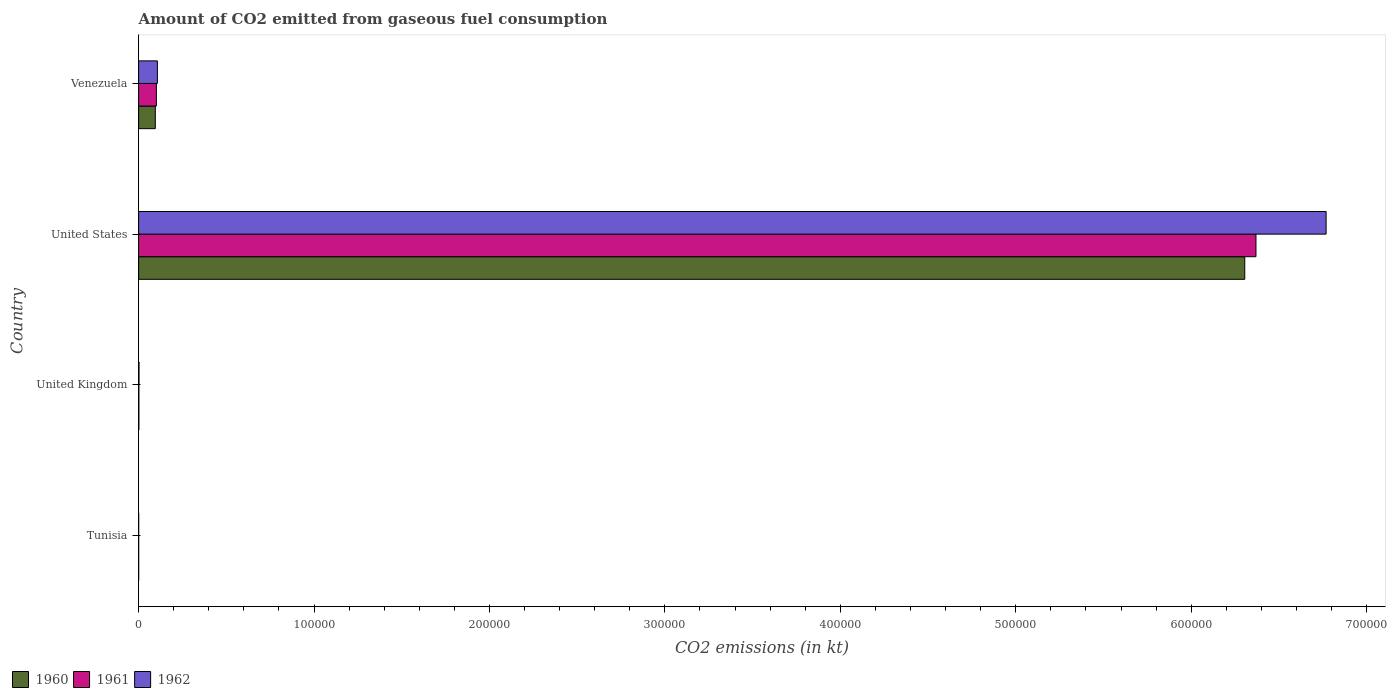How many different coloured bars are there?
Ensure brevity in your answer.  3. Are the number of bars on each tick of the Y-axis equal?
Offer a terse response. Yes. How many bars are there on the 1st tick from the top?
Keep it short and to the point. 3. How many bars are there on the 2nd tick from the bottom?
Give a very brief answer. 3. What is the label of the 3rd group of bars from the top?
Provide a short and direct response. United Kingdom. In how many cases, is the number of bars for a given country not equal to the number of legend labels?
Offer a very short reply. 0. What is the amount of CO2 emitted in 1962 in United Kingdom?
Keep it short and to the point. 216.35. Across all countries, what is the maximum amount of CO2 emitted in 1962?
Provide a short and direct response. 6.77e+05. Across all countries, what is the minimum amount of CO2 emitted in 1961?
Ensure brevity in your answer.  14.67. In which country was the amount of CO2 emitted in 1962 minimum?
Ensure brevity in your answer.  Tunisia. What is the total amount of CO2 emitted in 1960 in the graph?
Your answer should be very brief. 6.40e+05. What is the difference between the amount of CO2 emitted in 1961 in Tunisia and that in United Kingdom?
Provide a succinct answer. -135.68. What is the difference between the amount of CO2 emitted in 1960 in United States and the amount of CO2 emitted in 1961 in Venezuela?
Offer a terse response. 6.20e+05. What is the average amount of CO2 emitted in 1961 per country?
Keep it short and to the point. 1.62e+05. What is the difference between the amount of CO2 emitted in 1961 and amount of CO2 emitted in 1962 in Tunisia?
Offer a very short reply. 0. In how many countries, is the amount of CO2 emitted in 1961 greater than 660000 kt?
Keep it short and to the point. 0. What is the ratio of the amount of CO2 emitted in 1962 in United Kingdom to that in United States?
Provide a short and direct response. 0. Is the amount of CO2 emitted in 1960 in United Kingdom less than that in United States?
Offer a very short reply. Yes. What is the difference between the highest and the second highest amount of CO2 emitted in 1961?
Ensure brevity in your answer.  6.27e+05. What is the difference between the highest and the lowest amount of CO2 emitted in 1961?
Your response must be concise. 6.37e+05. In how many countries, is the amount of CO2 emitted in 1962 greater than the average amount of CO2 emitted in 1962 taken over all countries?
Provide a succinct answer. 1. What does the 2nd bar from the top in Venezuela represents?
Provide a succinct answer. 1961. Is it the case that in every country, the sum of the amount of CO2 emitted in 1962 and amount of CO2 emitted in 1960 is greater than the amount of CO2 emitted in 1961?
Your response must be concise. Yes. How many bars are there?
Provide a succinct answer. 12. Are all the bars in the graph horizontal?
Offer a very short reply. Yes. How many countries are there in the graph?
Keep it short and to the point. 4. What is the difference between two consecutive major ticks on the X-axis?
Provide a succinct answer. 1.00e+05. Does the graph contain grids?
Your response must be concise. No. How many legend labels are there?
Provide a short and direct response. 3. How are the legend labels stacked?
Your answer should be very brief. Horizontal. What is the title of the graph?
Offer a terse response. Amount of CO2 emitted from gaseous fuel consumption. Does "1965" appear as one of the legend labels in the graph?
Your answer should be compact. No. What is the label or title of the X-axis?
Make the answer very short. CO2 emissions (in kt). What is the CO2 emissions (in kt) of 1960 in Tunisia?
Ensure brevity in your answer.  14.67. What is the CO2 emissions (in kt) of 1961 in Tunisia?
Keep it short and to the point. 14.67. What is the CO2 emissions (in kt) in 1962 in Tunisia?
Ensure brevity in your answer.  14.67. What is the CO2 emissions (in kt) of 1960 in United Kingdom?
Offer a very short reply. 150.35. What is the CO2 emissions (in kt) of 1961 in United Kingdom?
Make the answer very short. 150.35. What is the CO2 emissions (in kt) in 1962 in United Kingdom?
Keep it short and to the point. 216.35. What is the CO2 emissions (in kt) in 1960 in United States?
Offer a very short reply. 6.31e+05. What is the CO2 emissions (in kt) in 1961 in United States?
Make the answer very short. 6.37e+05. What is the CO2 emissions (in kt) in 1962 in United States?
Offer a very short reply. 6.77e+05. What is the CO2 emissions (in kt) in 1960 in Venezuela?
Give a very brief answer. 9508.53. What is the CO2 emissions (in kt) in 1961 in Venezuela?
Provide a succinct answer. 1.01e+04. What is the CO2 emissions (in kt) in 1962 in Venezuela?
Offer a very short reply. 1.07e+04. Across all countries, what is the maximum CO2 emissions (in kt) in 1960?
Your answer should be compact. 6.31e+05. Across all countries, what is the maximum CO2 emissions (in kt) in 1961?
Ensure brevity in your answer.  6.37e+05. Across all countries, what is the maximum CO2 emissions (in kt) in 1962?
Provide a short and direct response. 6.77e+05. Across all countries, what is the minimum CO2 emissions (in kt) in 1960?
Make the answer very short. 14.67. Across all countries, what is the minimum CO2 emissions (in kt) of 1961?
Your answer should be very brief. 14.67. Across all countries, what is the minimum CO2 emissions (in kt) in 1962?
Provide a short and direct response. 14.67. What is the total CO2 emissions (in kt) in 1960 in the graph?
Offer a terse response. 6.40e+05. What is the total CO2 emissions (in kt) of 1961 in the graph?
Ensure brevity in your answer.  6.47e+05. What is the total CO2 emissions (in kt) in 1962 in the graph?
Provide a short and direct response. 6.88e+05. What is the difference between the CO2 emissions (in kt) of 1960 in Tunisia and that in United Kingdom?
Keep it short and to the point. -135.68. What is the difference between the CO2 emissions (in kt) in 1961 in Tunisia and that in United Kingdom?
Offer a very short reply. -135.68. What is the difference between the CO2 emissions (in kt) of 1962 in Tunisia and that in United Kingdom?
Offer a very short reply. -201.69. What is the difference between the CO2 emissions (in kt) of 1960 in Tunisia and that in United States?
Give a very brief answer. -6.31e+05. What is the difference between the CO2 emissions (in kt) of 1961 in Tunisia and that in United States?
Make the answer very short. -6.37e+05. What is the difference between the CO2 emissions (in kt) of 1962 in Tunisia and that in United States?
Offer a terse response. -6.77e+05. What is the difference between the CO2 emissions (in kt) in 1960 in Tunisia and that in Venezuela?
Keep it short and to the point. -9493.86. What is the difference between the CO2 emissions (in kt) in 1961 in Tunisia and that in Venezuela?
Keep it short and to the point. -1.01e+04. What is the difference between the CO2 emissions (in kt) in 1962 in Tunisia and that in Venezuela?
Your answer should be very brief. -1.07e+04. What is the difference between the CO2 emissions (in kt) of 1960 in United Kingdom and that in United States?
Give a very brief answer. -6.30e+05. What is the difference between the CO2 emissions (in kt) of 1961 in United Kingdom and that in United States?
Offer a terse response. -6.37e+05. What is the difference between the CO2 emissions (in kt) of 1962 in United Kingdom and that in United States?
Your answer should be compact. -6.77e+05. What is the difference between the CO2 emissions (in kt) in 1960 in United Kingdom and that in Venezuela?
Ensure brevity in your answer.  -9358.18. What is the difference between the CO2 emissions (in kt) of 1961 in United Kingdom and that in Venezuela?
Your answer should be very brief. -9970.57. What is the difference between the CO2 emissions (in kt) in 1962 in United Kingdom and that in Venezuela?
Offer a terse response. -1.05e+04. What is the difference between the CO2 emissions (in kt) in 1960 in United States and that in Venezuela?
Make the answer very short. 6.21e+05. What is the difference between the CO2 emissions (in kt) in 1961 in United States and that in Venezuela?
Make the answer very short. 6.27e+05. What is the difference between the CO2 emissions (in kt) of 1962 in United States and that in Venezuela?
Your answer should be compact. 6.66e+05. What is the difference between the CO2 emissions (in kt) in 1960 in Tunisia and the CO2 emissions (in kt) in 1961 in United Kingdom?
Offer a terse response. -135.68. What is the difference between the CO2 emissions (in kt) of 1960 in Tunisia and the CO2 emissions (in kt) of 1962 in United Kingdom?
Offer a terse response. -201.69. What is the difference between the CO2 emissions (in kt) of 1961 in Tunisia and the CO2 emissions (in kt) of 1962 in United Kingdom?
Your answer should be very brief. -201.69. What is the difference between the CO2 emissions (in kt) of 1960 in Tunisia and the CO2 emissions (in kt) of 1961 in United States?
Give a very brief answer. -6.37e+05. What is the difference between the CO2 emissions (in kt) in 1960 in Tunisia and the CO2 emissions (in kt) in 1962 in United States?
Ensure brevity in your answer.  -6.77e+05. What is the difference between the CO2 emissions (in kt) of 1961 in Tunisia and the CO2 emissions (in kt) of 1962 in United States?
Offer a terse response. -6.77e+05. What is the difference between the CO2 emissions (in kt) of 1960 in Tunisia and the CO2 emissions (in kt) of 1961 in Venezuela?
Your answer should be very brief. -1.01e+04. What is the difference between the CO2 emissions (in kt) of 1960 in Tunisia and the CO2 emissions (in kt) of 1962 in Venezuela?
Ensure brevity in your answer.  -1.07e+04. What is the difference between the CO2 emissions (in kt) of 1961 in Tunisia and the CO2 emissions (in kt) of 1962 in Venezuela?
Provide a short and direct response. -1.07e+04. What is the difference between the CO2 emissions (in kt) of 1960 in United Kingdom and the CO2 emissions (in kt) of 1961 in United States?
Give a very brief answer. -6.37e+05. What is the difference between the CO2 emissions (in kt) of 1960 in United Kingdom and the CO2 emissions (in kt) of 1962 in United States?
Your response must be concise. -6.77e+05. What is the difference between the CO2 emissions (in kt) in 1961 in United Kingdom and the CO2 emissions (in kt) in 1962 in United States?
Your answer should be compact. -6.77e+05. What is the difference between the CO2 emissions (in kt) of 1960 in United Kingdom and the CO2 emissions (in kt) of 1961 in Venezuela?
Keep it short and to the point. -9970.57. What is the difference between the CO2 emissions (in kt) in 1960 in United Kingdom and the CO2 emissions (in kt) in 1962 in Venezuela?
Your answer should be very brief. -1.05e+04. What is the difference between the CO2 emissions (in kt) in 1961 in United Kingdom and the CO2 emissions (in kt) in 1962 in Venezuela?
Offer a terse response. -1.05e+04. What is the difference between the CO2 emissions (in kt) of 1960 in United States and the CO2 emissions (in kt) of 1961 in Venezuela?
Provide a succinct answer. 6.20e+05. What is the difference between the CO2 emissions (in kt) of 1960 in United States and the CO2 emissions (in kt) of 1962 in Venezuela?
Give a very brief answer. 6.20e+05. What is the difference between the CO2 emissions (in kt) of 1961 in United States and the CO2 emissions (in kt) of 1962 in Venezuela?
Ensure brevity in your answer.  6.26e+05. What is the average CO2 emissions (in kt) of 1960 per country?
Make the answer very short. 1.60e+05. What is the average CO2 emissions (in kt) in 1961 per country?
Provide a short and direct response. 1.62e+05. What is the average CO2 emissions (in kt) of 1962 per country?
Your response must be concise. 1.72e+05. What is the difference between the CO2 emissions (in kt) of 1960 and CO2 emissions (in kt) of 1961 in Tunisia?
Give a very brief answer. 0. What is the difference between the CO2 emissions (in kt) of 1960 and CO2 emissions (in kt) of 1962 in Tunisia?
Give a very brief answer. 0. What is the difference between the CO2 emissions (in kt) of 1961 and CO2 emissions (in kt) of 1962 in Tunisia?
Keep it short and to the point. 0. What is the difference between the CO2 emissions (in kt) of 1960 and CO2 emissions (in kt) of 1962 in United Kingdom?
Give a very brief answer. -66.01. What is the difference between the CO2 emissions (in kt) of 1961 and CO2 emissions (in kt) of 1962 in United Kingdom?
Your response must be concise. -66.01. What is the difference between the CO2 emissions (in kt) of 1960 and CO2 emissions (in kt) of 1961 in United States?
Provide a short and direct response. -6395.25. What is the difference between the CO2 emissions (in kt) of 1960 and CO2 emissions (in kt) of 1962 in United States?
Offer a terse response. -4.64e+04. What is the difference between the CO2 emissions (in kt) of 1961 and CO2 emissions (in kt) of 1962 in United States?
Your answer should be compact. -4.00e+04. What is the difference between the CO2 emissions (in kt) of 1960 and CO2 emissions (in kt) of 1961 in Venezuela?
Offer a very short reply. -612.39. What is the difference between the CO2 emissions (in kt) of 1960 and CO2 emissions (in kt) of 1962 in Venezuela?
Provide a succinct answer. -1191.78. What is the difference between the CO2 emissions (in kt) of 1961 and CO2 emissions (in kt) of 1962 in Venezuela?
Ensure brevity in your answer.  -579.39. What is the ratio of the CO2 emissions (in kt) in 1960 in Tunisia to that in United Kingdom?
Make the answer very short. 0.1. What is the ratio of the CO2 emissions (in kt) in 1961 in Tunisia to that in United Kingdom?
Your response must be concise. 0.1. What is the ratio of the CO2 emissions (in kt) in 1962 in Tunisia to that in United Kingdom?
Keep it short and to the point. 0.07. What is the ratio of the CO2 emissions (in kt) in 1960 in Tunisia to that in United States?
Provide a short and direct response. 0. What is the ratio of the CO2 emissions (in kt) in 1961 in Tunisia to that in United States?
Make the answer very short. 0. What is the ratio of the CO2 emissions (in kt) of 1960 in Tunisia to that in Venezuela?
Make the answer very short. 0. What is the ratio of the CO2 emissions (in kt) in 1961 in Tunisia to that in Venezuela?
Keep it short and to the point. 0. What is the ratio of the CO2 emissions (in kt) in 1962 in Tunisia to that in Venezuela?
Keep it short and to the point. 0. What is the ratio of the CO2 emissions (in kt) of 1960 in United Kingdom to that in Venezuela?
Ensure brevity in your answer.  0.02. What is the ratio of the CO2 emissions (in kt) of 1961 in United Kingdom to that in Venezuela?
Make the answer very short. 0.01. What is the ratio of the CO2 emissions (in kt) in 1962 in United Kingdom to that in Venezuela?
Your response must be concise. 0.02. What is the ratio of the CO2 emissions (in kt) of 1960 in United States to that in Venezuela?
Offer a very short reply. 66.31. What is the ratio of the CO2 emissions (in kt) of 1961 in United States to that in Venezuela?
Ensure brevity in your answer.  62.93. What is the ratio of the CO2 emissions (in kt) of 1962 in United States to that in Venezuela?
Offer a very short reply. 63.26. What is the difference between the highest and the second highest CO2 emissions (in kt) in 1960?
Give a very brief answer. 6.21e+05. What is the difference between the highest and the second highest CO2 emissions (in kt) in 1961?
Ensure brevity in your answer.  6.27e+05. What is the difference between the highest and the second highest CO2 emissions (in kt) in 1962?
Offer a terse response. 6.66e+05. What is the difference between the highest and the lowest CO2 emissions (in kt) in 1960?
Ensure brevity in your answer.  6.31e+05. What is the difference between the highest and the lowest CO2 emissions (in kt) of 1961?
Offer a very short reply. 6.37e+05. What is the difference between the highest and the lowest CO2 emissions (in kt) in 1962?
Offer a terse response. 6.77e+05. 